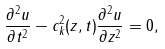Convert formula to latex. <formula><loc_0><loc_0><loc_500><loc_500>\frac { \partial ^ { 2 } u } { \partial t ^ { 2 } } - c _ { k } ^ { 2 } ( z , t ) \frac { \partial ^ { 2 } u } { \partial z ^ { 2 } } = 0 ,</formula> 